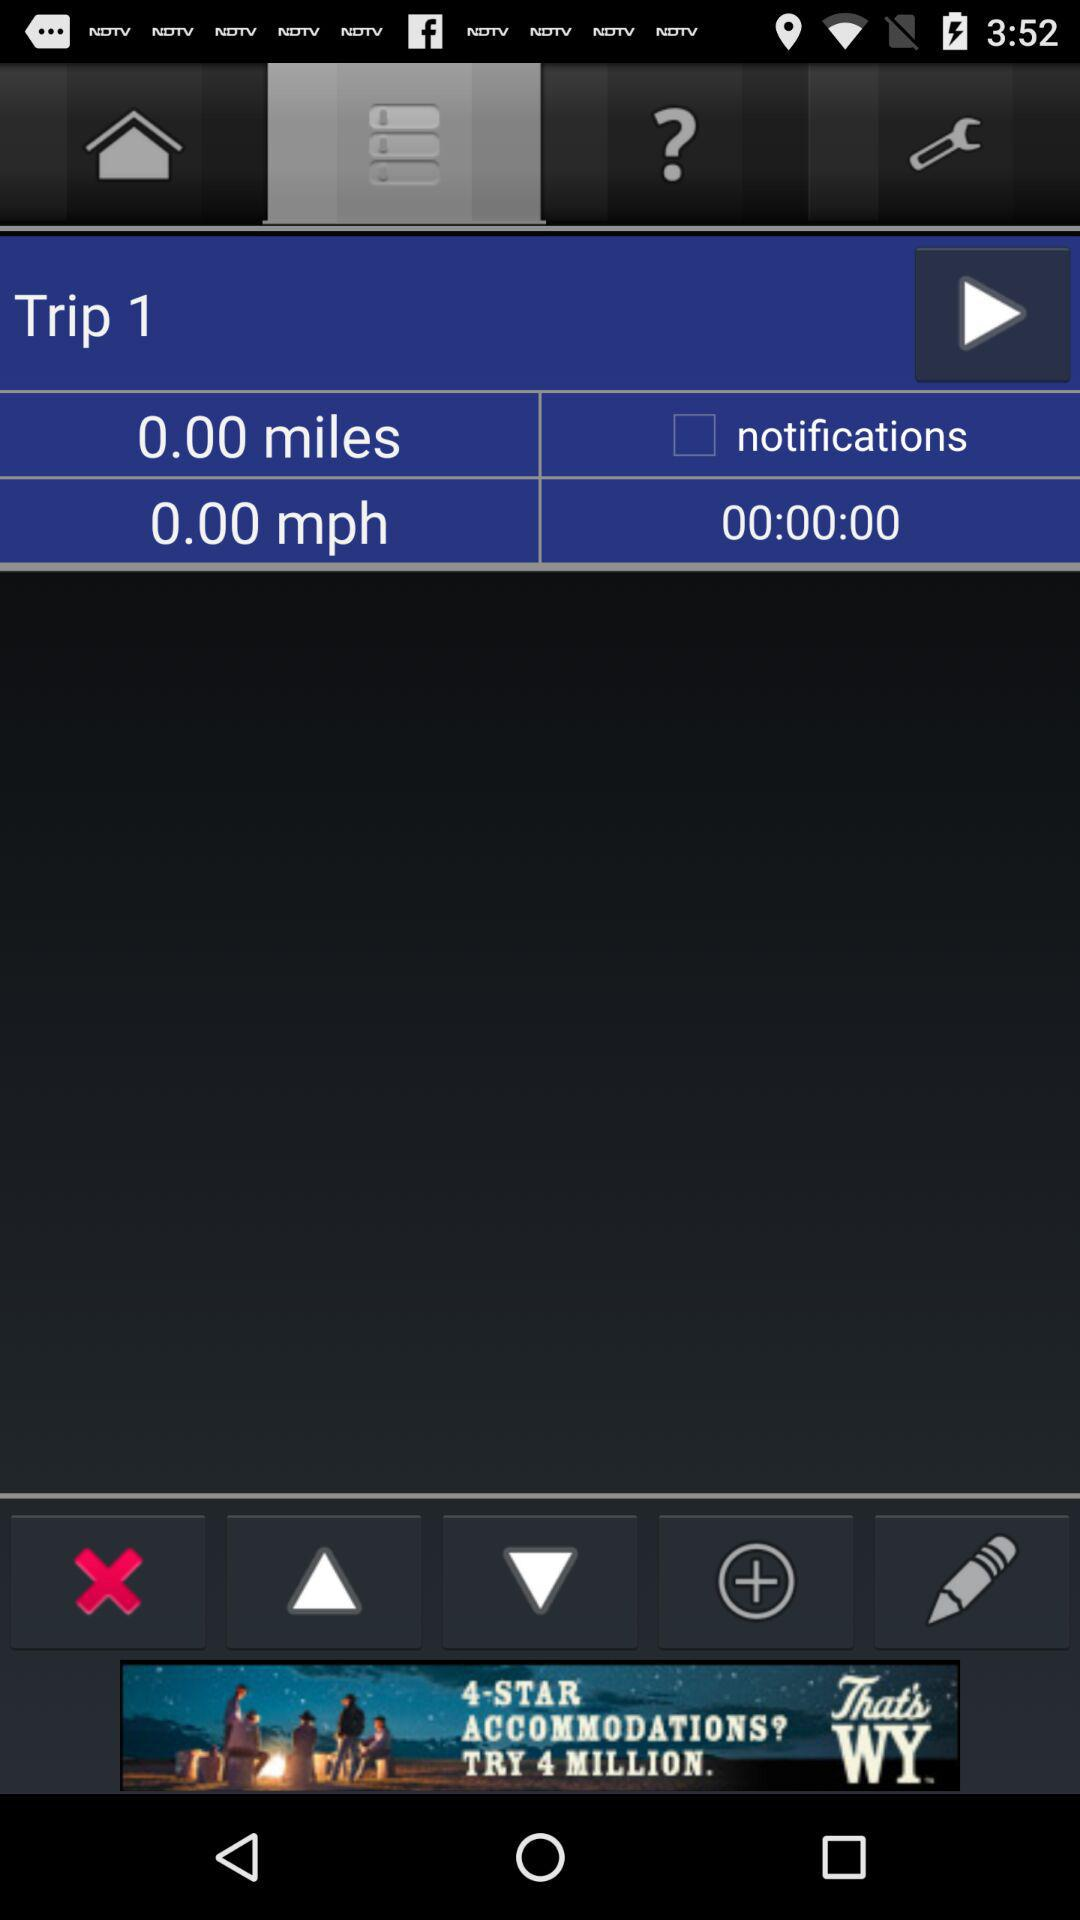How many miles have been driven on this trip?
Answer the question using a single word or phrase. 0.00 miles 